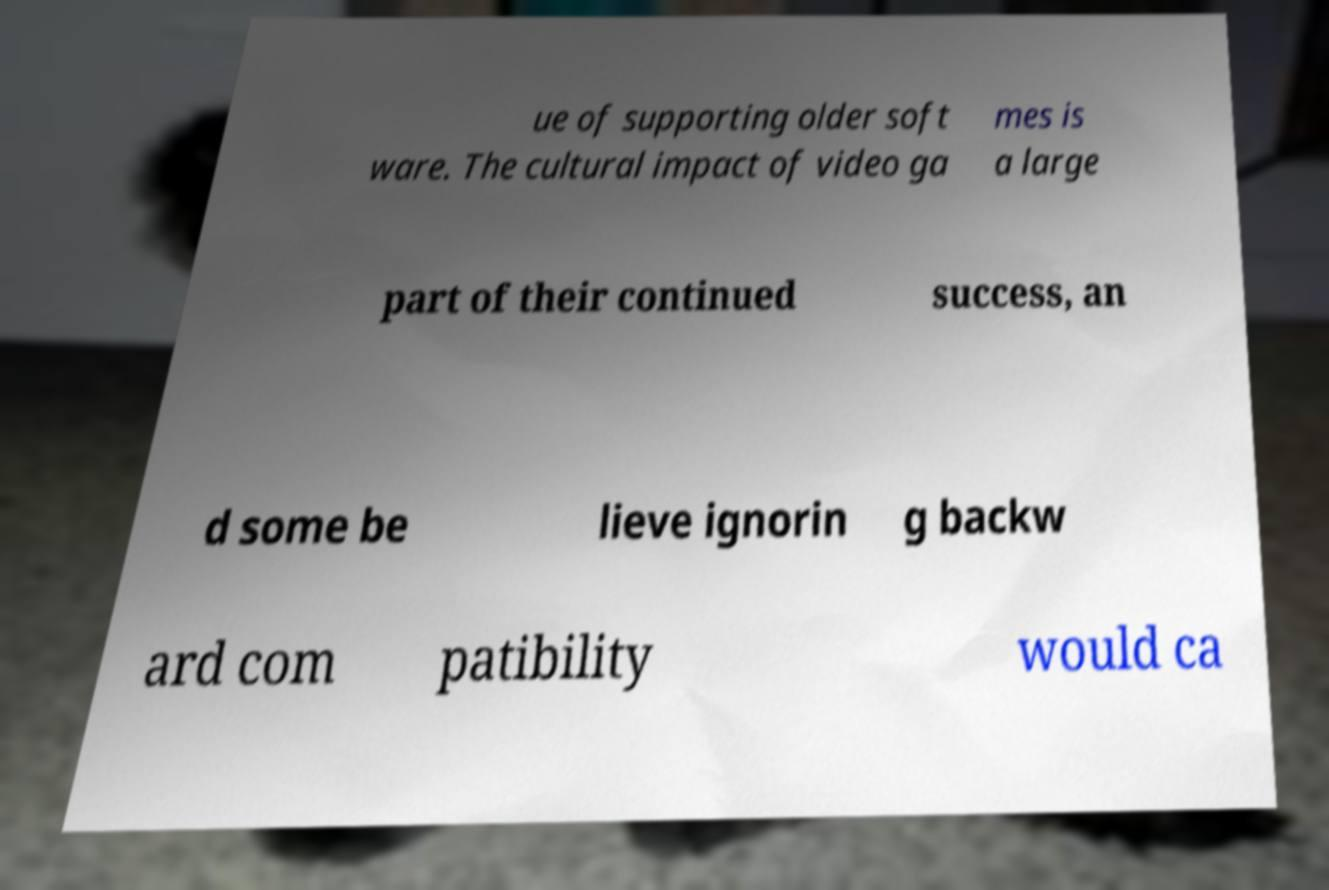Could you assist in decoding the text presented in this image and type it out clearly? ue of supporting older soft ware. The cultural impact of video ga mes is a large part of their continued success, an d some be lieve ignorin g backw ard com patibility would ca 